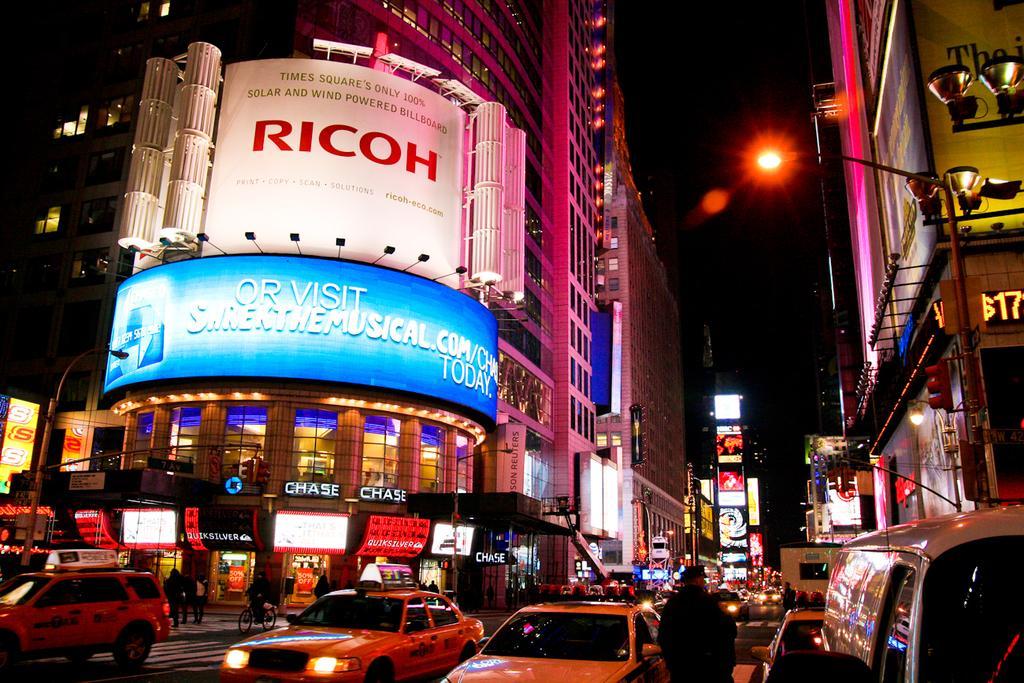How would you summarize this image in a sentence or two? The image is clicked outside a city. In the foreground of the picture there are vehicles and road. Towards left there are boards, buildings. In the center of the picture there are vehicles, people, boards and sky. On the right we can see buildings, street light, signal boards and other objects. 